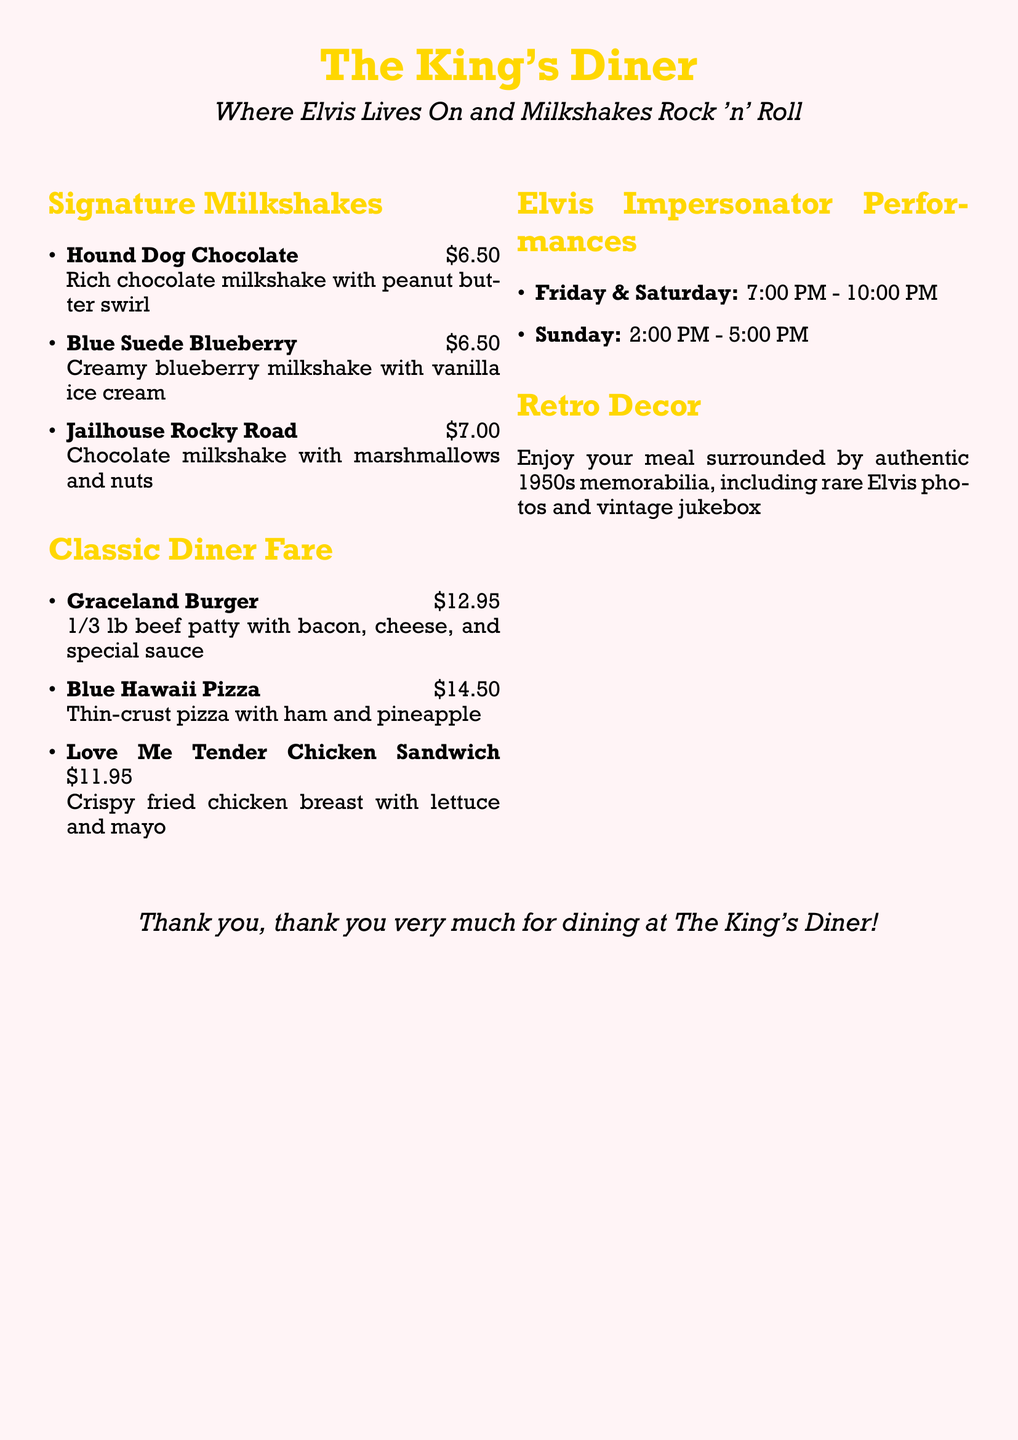What are the hours for Elvis impersonator performances on Friday? The document specifies the performance hours as 7:00 PM - 10:00 PM on Friday.
Answer: 7:00 PM - 10:00 PM What is the price of the Jailhouse Rocky Road milkshake? The document lists the price of the Jailhouse Rocky Road milkshake as $7.00.
Answer: $7.00 What type of decor can guests expect in The King's Diner? The document mentions that guests can enjoy 1950s memorabilia including rare Elvis photos and a vintage jukebox.
Answer: 1950s memorabilia How much does the Graceland Burger cost? The Graceland Burger is priced at $12.95, as indicated in the menu.
Answer: $12.95 What is served with the Love Me Tender Chicken Sandwich? The document states that it comes with crispy fried chicken breast, lettuce, and mayo.
Answer: Lettuce and mayo On which day does the Elvis impersonator perform in the afternoon? According to the document, the afternoon performance is scheduled for Sunday from 2:00 PM - 5:00 PM.
Answer: Sunday What flavor is the Blue Suede Blueberry milkshake? The document describes the Blue Suede Blueberry milkshake as creamy blueberry with vanilla ice cream.
Answer: Creamy blueberry What is the special sauce included in the Graceland Burger? The document refers to "special sauce" but does not provide a specific name or details.
Answer: Special sauce 